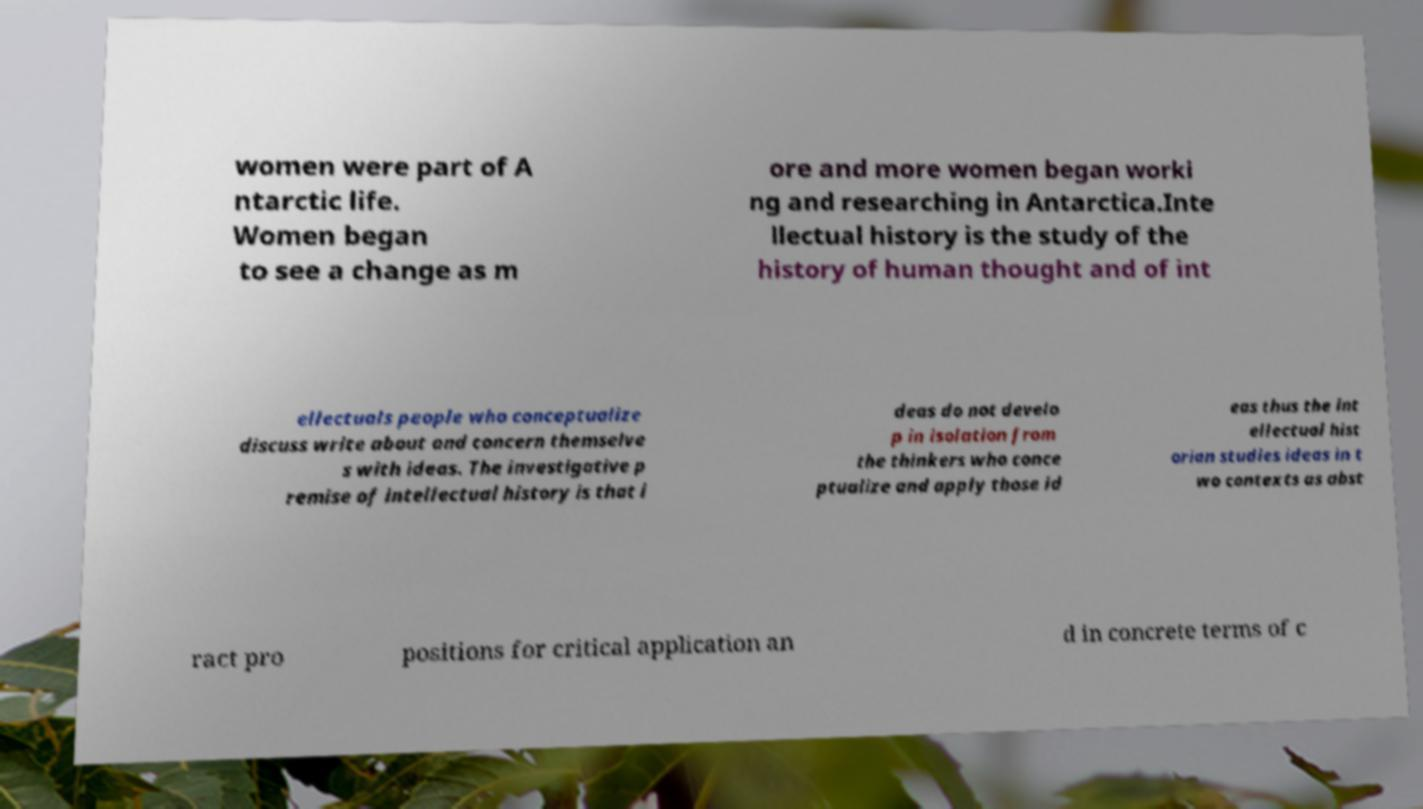Can you read and provide the text displayed in the image?This photo seems to have some interesting text. Can you extract and type it out for me? women were part of A ntarctic life. Women began to see a change as m ore and more women began worki ng and researching in Antarctica.Inte llectual history is the study of the history of human thought and of int ellectuals people who conceptualize discuss write about and concern themselve s with ideas. The investigative p remise of intellectual history is that i deas do not develo p in isolation from the thinkers who conce ptualize and apply those id eas thus the int ellectual hist orian studies ideas in t wo contexts as abst ract pro positions for critical application an d in concrete terms of c 